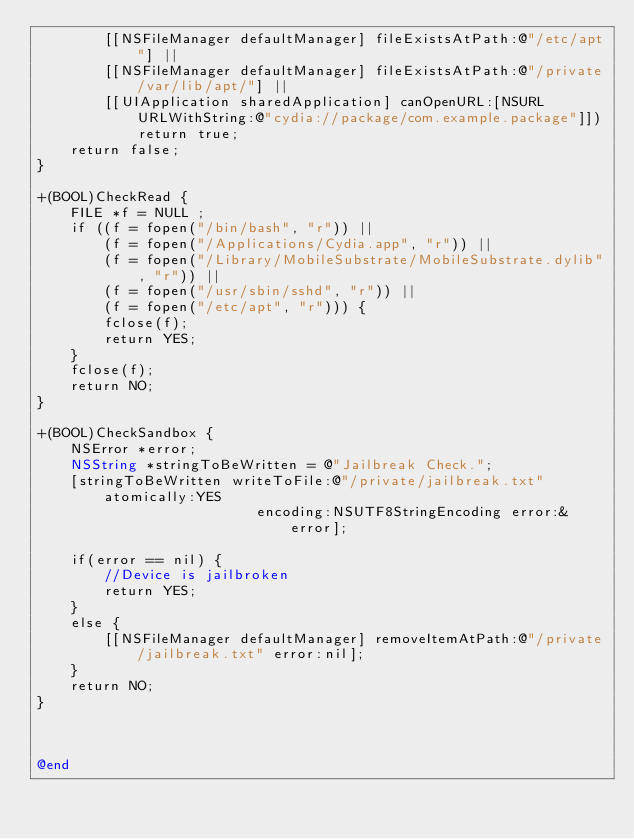Convert code to text. <code><loc_0><loc_0><loc_500><loc_500><_ObjectiveC_>        [[NSFileManager defaultManager] fileExistsAtPath:@"/etc/apt"] ||
        [[NSFileManager defaultManager] fileExistsAtPath:@"/private/var/lib/apt/"] ||
        [[UIApplication sharedApplication] canOpenURL:[NSURL URLWithString:@"cydia://package/com.example.package"]])
            return true;
    return false;
}

+(BOOL)CheckRead {
    FILE *f = NULL ;
    if ((f = fopen("/bin/bash", "r")) ||
        (f = fopen("/Applications/Cydia.app", "r")) ||
        (f = fopen("/Library/MobileSubstrate/MobileSubstrate.dylib", "r")) ||
        (f = fopen("/usr/sbin/sshd", "r")) ||
        (f = fopen("/etc/apt", "r"))) {
        fclose(f);
        return YES;
    }
    fclose(f);
    return NO;
}

+(BOOL)CheckSandbox {
    NSError *error;
    NSString *stringToBeWritten = @"Jailbreak Check.";
    [stringToBeWritten writeToFile:@"/private/jailbreak.txt" atomically:YES
                          encoding:NSUTF8StringEncoding error:&error];
    
    if(error == nil) {
        //Device is jailbroken
        return YES;
    }
    else {
        [[NSFileManager defaultManager] removeItemAtPath:@"/private/jailbreak.txt" error:nil];
    }
    return NO;
}



@end
</code> 